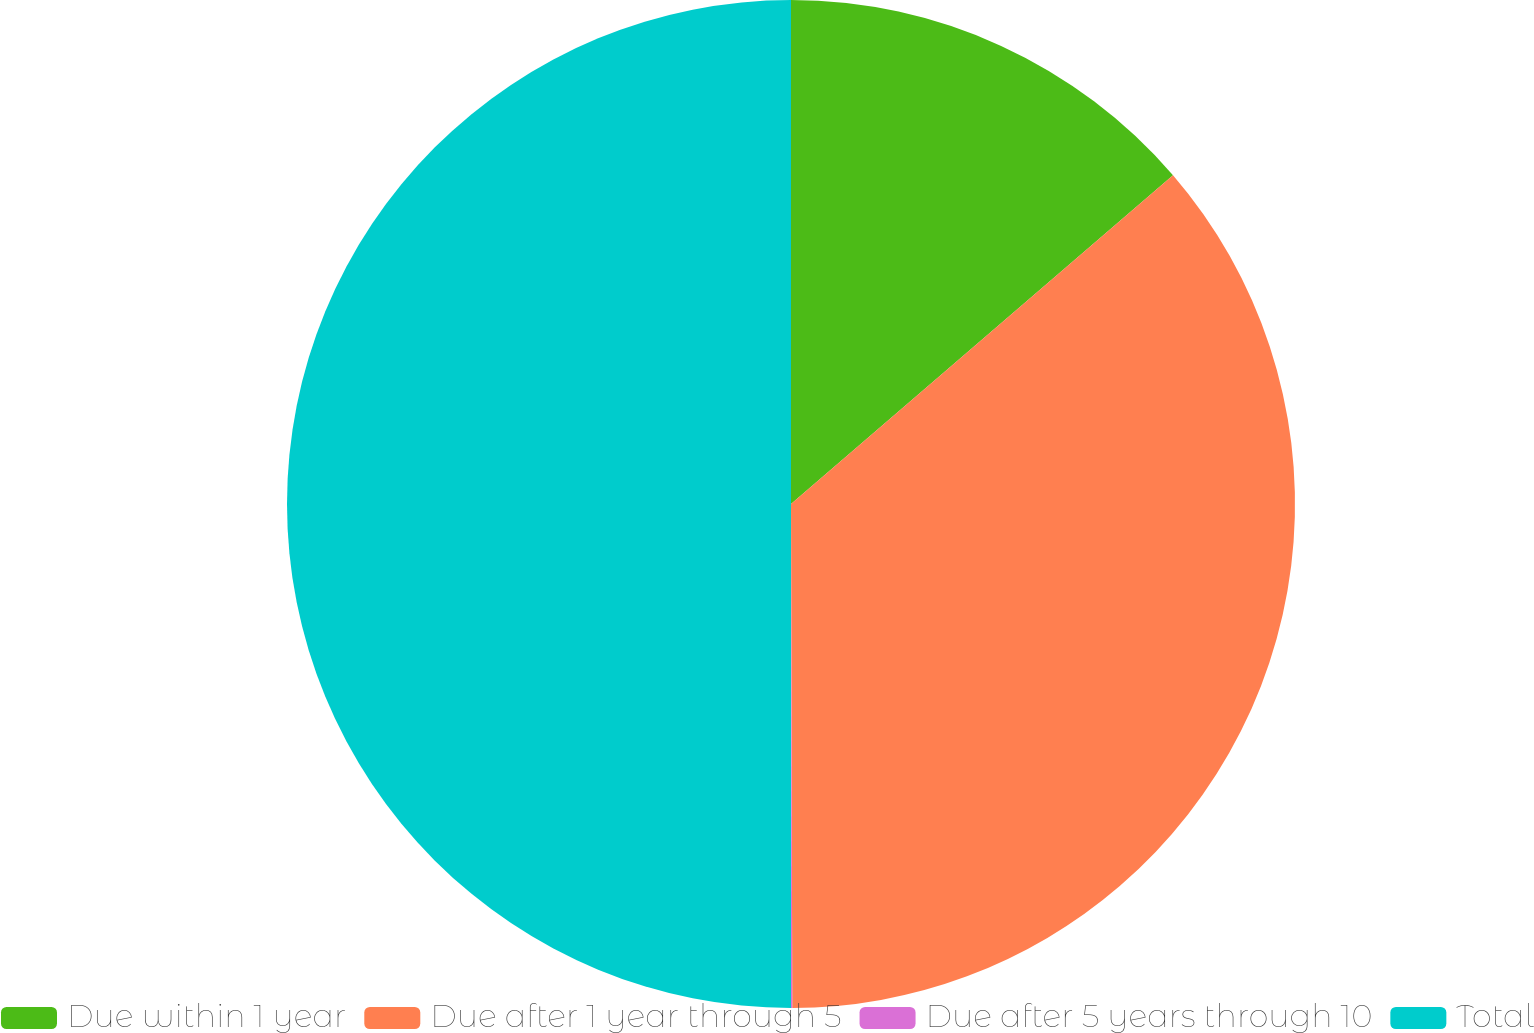Convert chart to OTSL. <chart><loc_0><loc_0><loc_500><loc_500><pie_chart><fcel>Due within 1 year<fcel>Due after 1 year through 5<fcel>Due after 5 years through 10<fcel>Total<nl><fcel>13.69%<fcel>36.27%<fcel>0.04%<fcel>50.0%<nl></chart> 